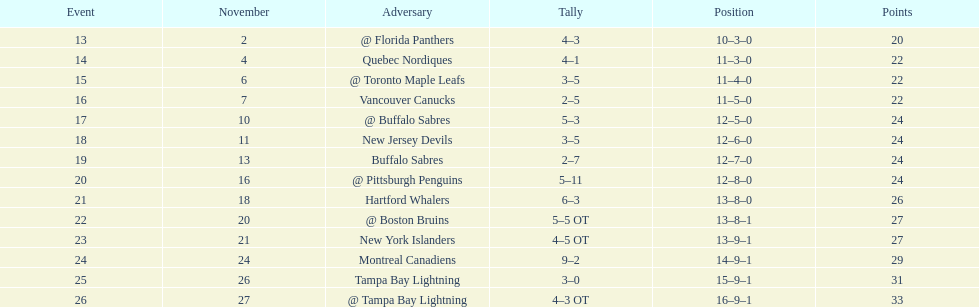Which was the only team in the atlantic division in the 1993-1994 season to acquire less points than the philadelphia flyers? Tampa Bay Lightning. 